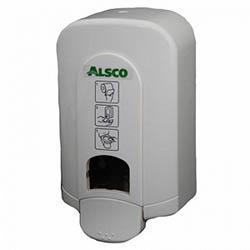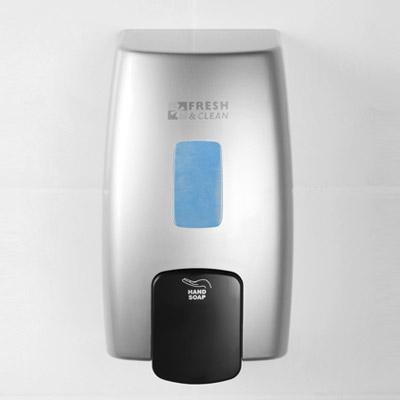The first image is the image on the left, the second image is the image on the right. For the images displayed, is the sentence "The cylindrical dispenser in one of the images has a thin tube on the spout." factually correct? Answer yes or no. No. 